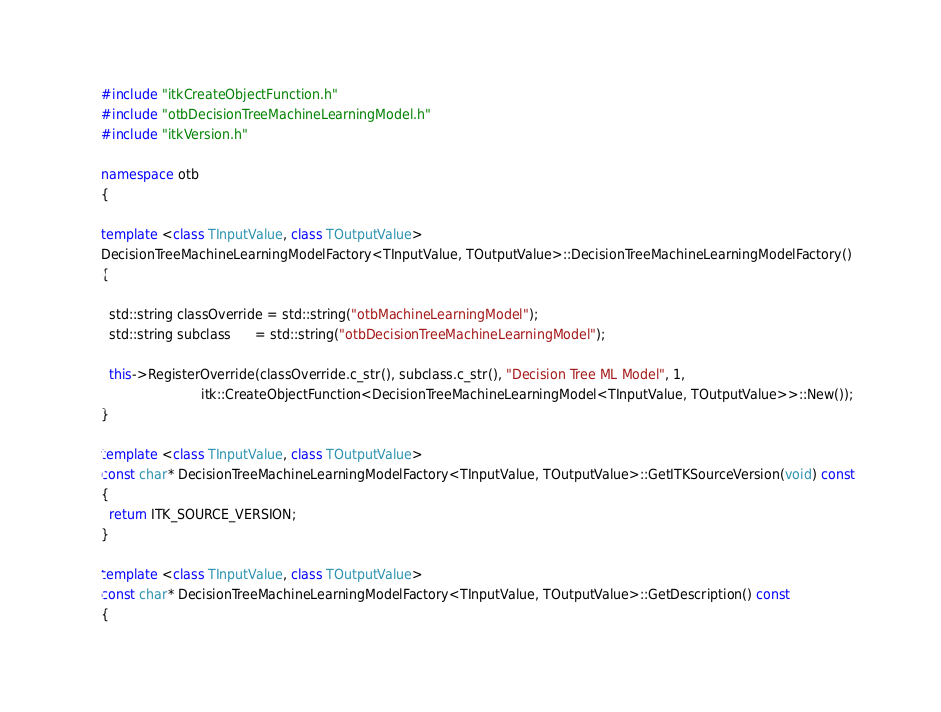Convert code to text. <code><loc_0><loc_0><loc_500><loc_500><_C++_>
#include "itkCreateObjectFunction.h"
#include "otbDecisionTreeMachineLearningModel.h"
#include "itkVersion.h"

namespace otb
{

template <class TInputValue, class TOutputValue>
DecisionTreeMachineLearningModelFactory<TInputValue, TOutputValue>::DecisionTreeMachineLearningModelFactory()
{

  std::string classOverride = std::string("otbMachineLearningModel");
  std::string subclass      = std::string("otbDecisionTreeMachineLearningModel");

  this->RegisterOverride(classOverride.c_str(), subclass.c_str(), "Decision Tree ML Model", 1,
                         itk::CreateObjectFunction<DecisionTreeMachineLearningModel<TInputValue, TOutputValue>>::New());
}

template <class TInputValue, class TOutputValue>
const char* DecisionTreeMachineLearningModelFactory<TInputValue, TOutputValue>::GetITKSourceVersion(void) const
{
  return ITK_SOURCE_VERSION;
}

template <class TInputValue, class TOutputValue>
const char* DecisionTreeMachineLearningModelFactory<TInputValue, TOutputValue>::GetDescription() const
{</code> 